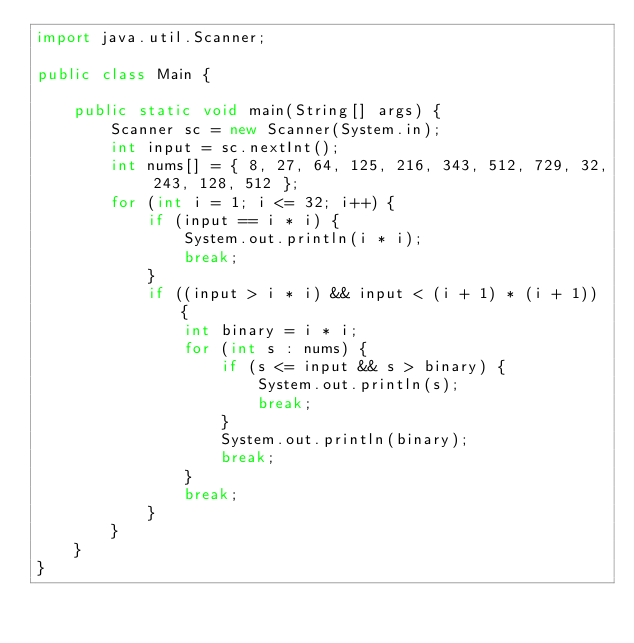<code> <loc_0><loc_0><loc_500><loc_500><_Java_>import java.util.Scanner;

public class Main {

	public static void main(String[] args) {
		Scanner sc = new Scanner(System.in);
		int input = sc.nextInt();
		int nums[] = { 8, 27, 64, 125, 216, 343, 512, 729, 32, 243, 128, 512 };
		for (int i = 1; i <= 32; i++) {
			if (input == i * i) {
				System.out.println(i * i);
				break;
			}
			if ((input > i * i) && input < (i + 1) * (i + 1)) {
				int binary = i * i;
				for (int s : nums) {
					if (s <= input && s > binary) {
						System.out.println(s);
						break;
					}
					System.out.println(binary);
					break;
				}
				break;
			}
		}
	}
}</code> 